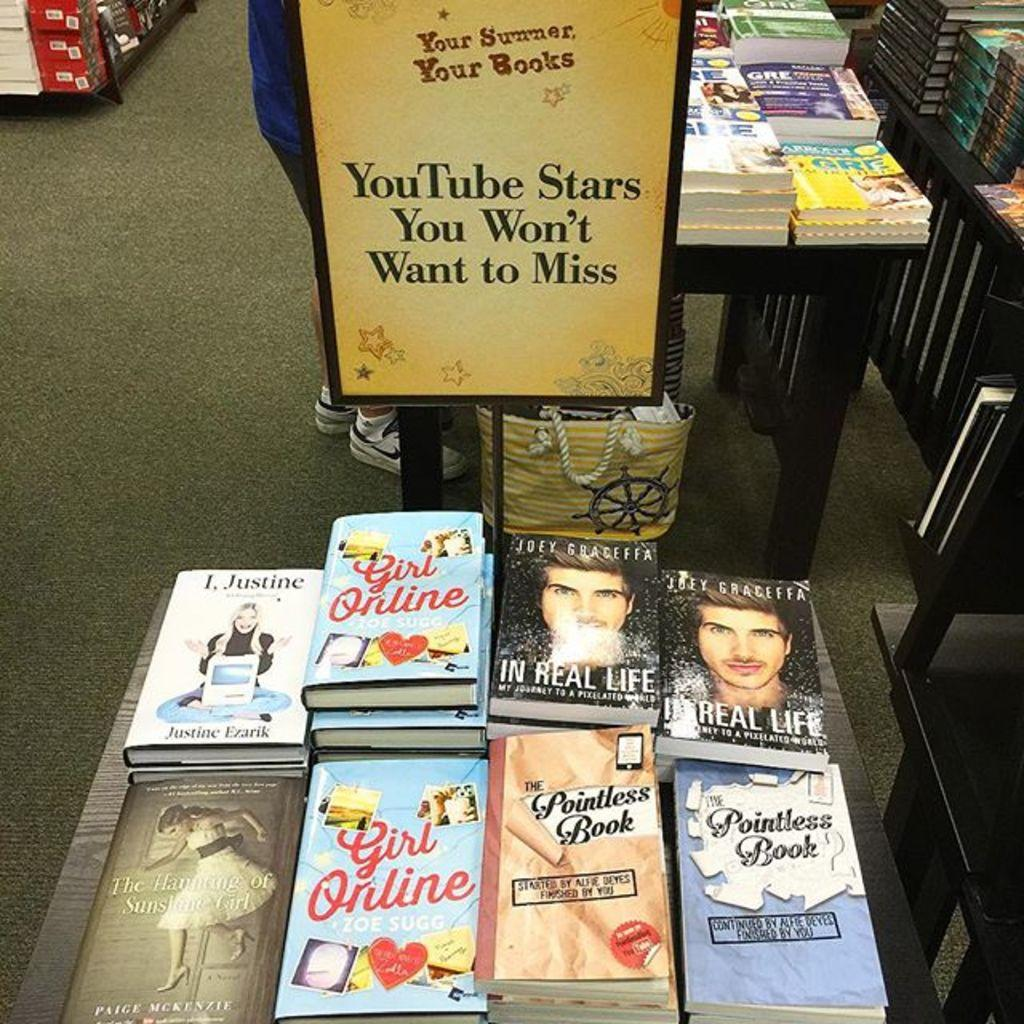What objects can be seen on the tables in the image? There are books on the tables in the image. Can you describe the person in the image? There is a person in the image, but no specific details about their appearance or actions are provided. What else is visible in the image besides the books and person? There is a bag and a board in the image. What is written on the board? Something is written on the board, but the specific content is not mentioned in the facts. What type of berry is the person eating in the image? There is no berry present in the image, and the person's actions are not described. Is the person's mother or uncle in the image? The facts do not mention any family members or relationships, so we cannot determine if the person's mother or uncle is in the image. 